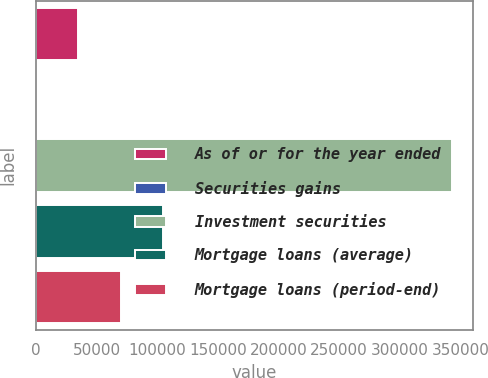<chart> <loc_0><loc_0><loc_500><loc_500><bar_chart><fcel>As of or for the year ended<fcel>Securities gains<fcel>Investment securities<fcel>Mortgage loans (average)<fcel>Mortgage loans (period-end)<nl><fcel>34992.4<fcel>71<fcel>343146<fcel>104835<fcel>69913.8<nl></chart> 